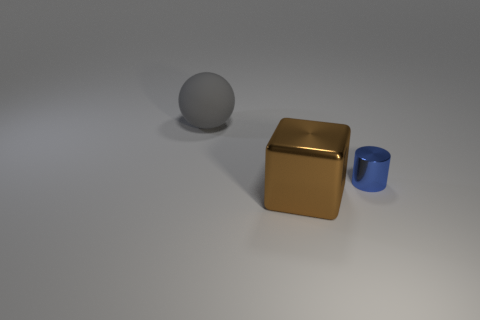There is a metal object that is behind the thing in front of the thing to the right of the big brown cube; what is its color?
Your answer should be very brief. Blue. The thing that is both behind the big brown block and on the right side of the big gray rubber thing has what shape?
Ensure brevity in your answer.  Cylinder. How many other things are the same shape as the large gray matte object?
Your answer should be compact. 0. The metallic object behind the big thing in front of the big object on the left side of the brown metal object is what shape?
Offer a terse response. Cylinder. What number of objects are tiny gray metal cylinders or big objects to the right of the large gray rubber sphere?
Your response must be concise. 1. Does the shiny thing that is behind the block have the same shape as the large thing that is on the right side of the large matte ball?
Offer a terse response. No. What number of objects are gray cylinders or tiny blue cylinders?
Your answer should be very brief. 1. Are there any other things that have the same material as the small object?
Make the answer very short. Yes. Are any large green matte cylinders visible?
Give a very brief answer. No. Do the large object behind the metal cylinder and the big brown block have the same material?
Make the answer very short. No. 